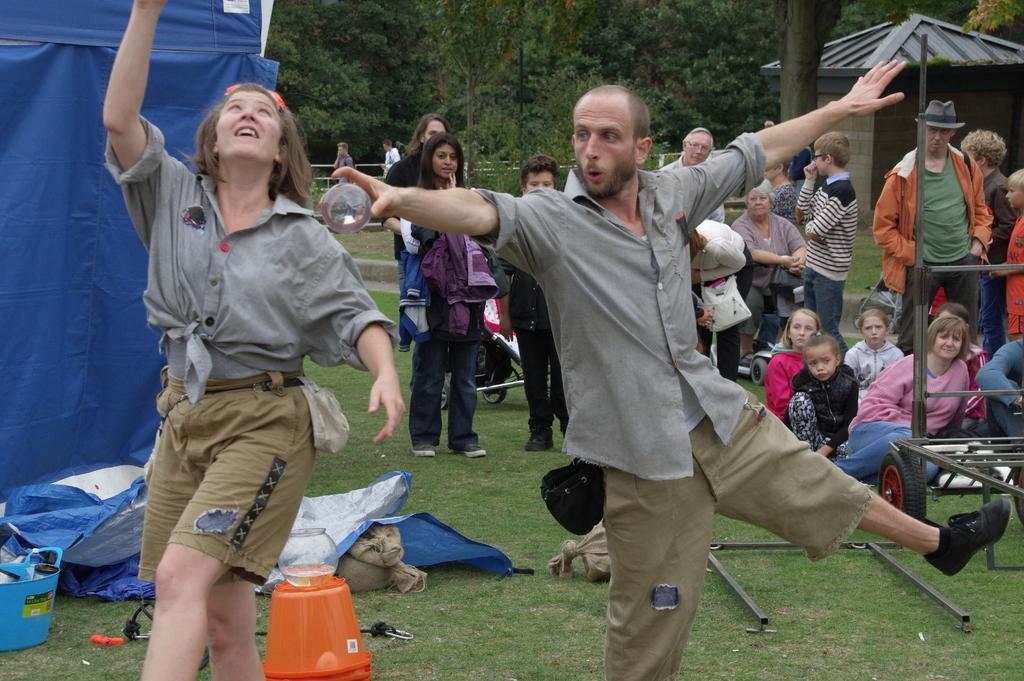Can you describe this image briefly? In this image, I can see the man and woman dancing. There are few people sitting and few people standing. This looks like a tent, which is blue in color. I can see a bucket, basket and few other things on the grass. On the right side of the image, that looks like a wheel cart. I think this is a shelter. These are the trees. Here is the grass. 